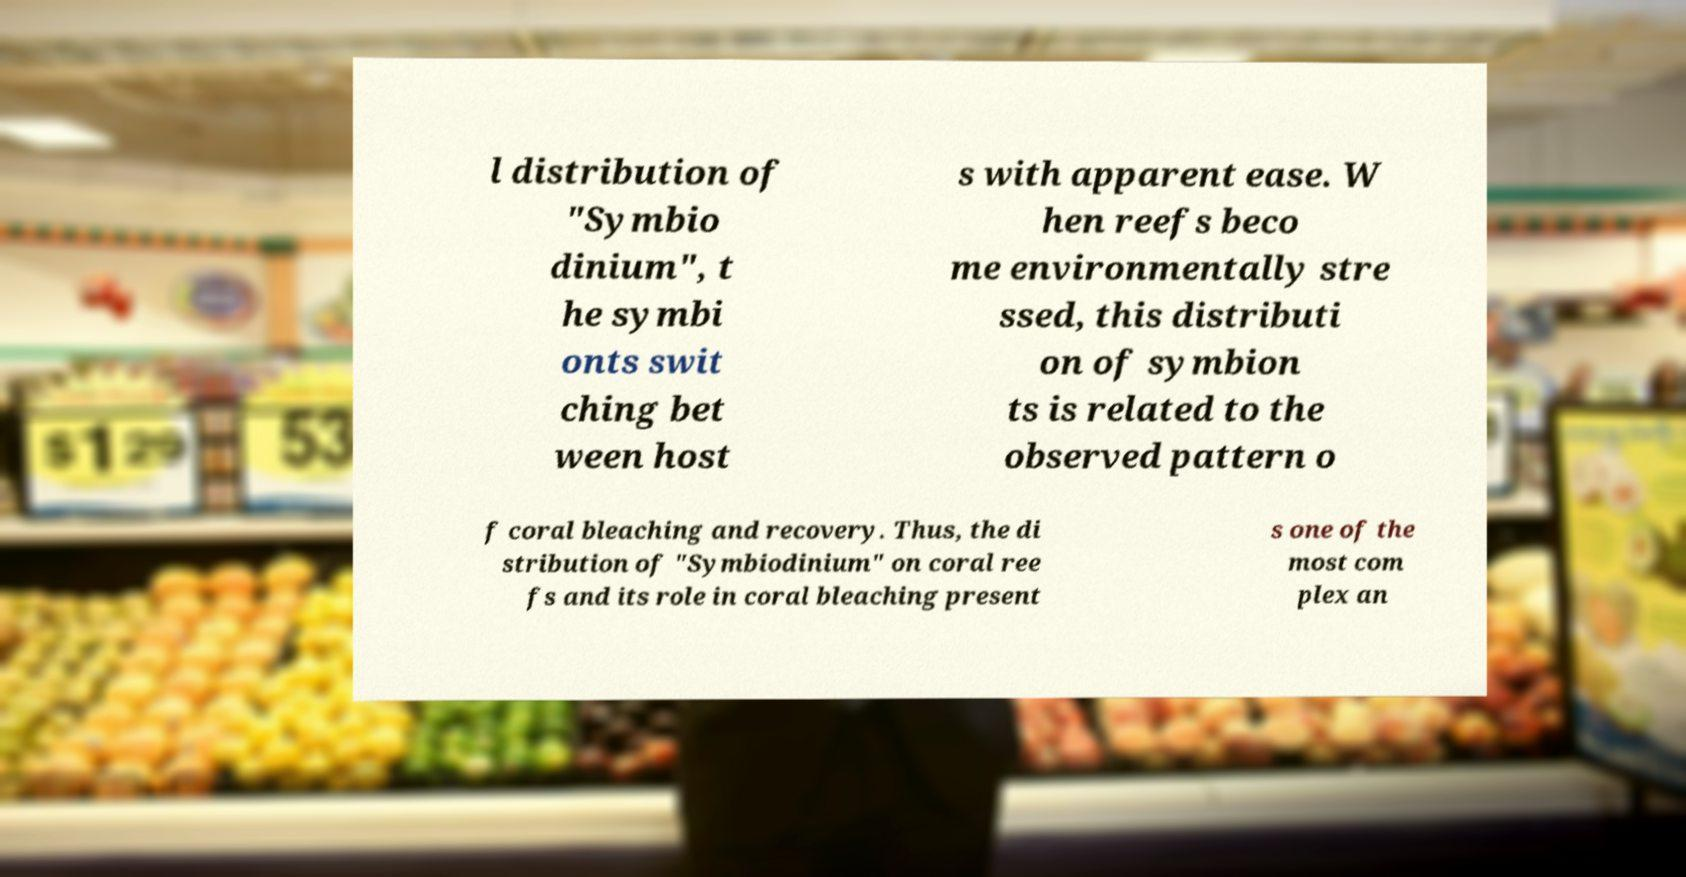Can you accurately transcribe the text from the provided image for me? l distribution of "Symbio dinium", t he symbi onts swit ching bet ween host s with apparent ease. W hen reefs beco me environmentally stre ssed, this distributi on of symbion ts is related to the observed pattern o f coral bleaching and recovery. Thus, the di stribution of "Symbiodinium" on coral ree fs and its role in coral bleaching present s one of the most com plex an 